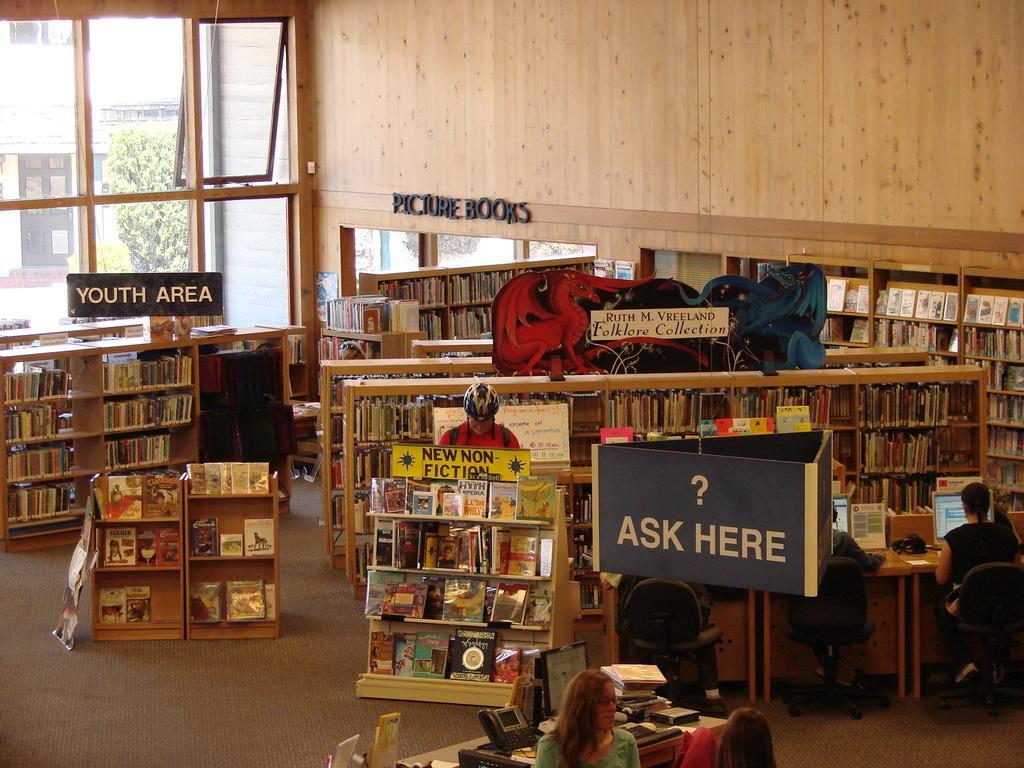In one or two sentences, can you explain what this image depicts? In this image we can see there are so many books arranged in the racks, there are a few boards with some text on it and there are a few people sitting in front of the table, on which there are monitors and a few other objects. In the background there is a wall and glass windows through which we can see there are trees and buildings. 